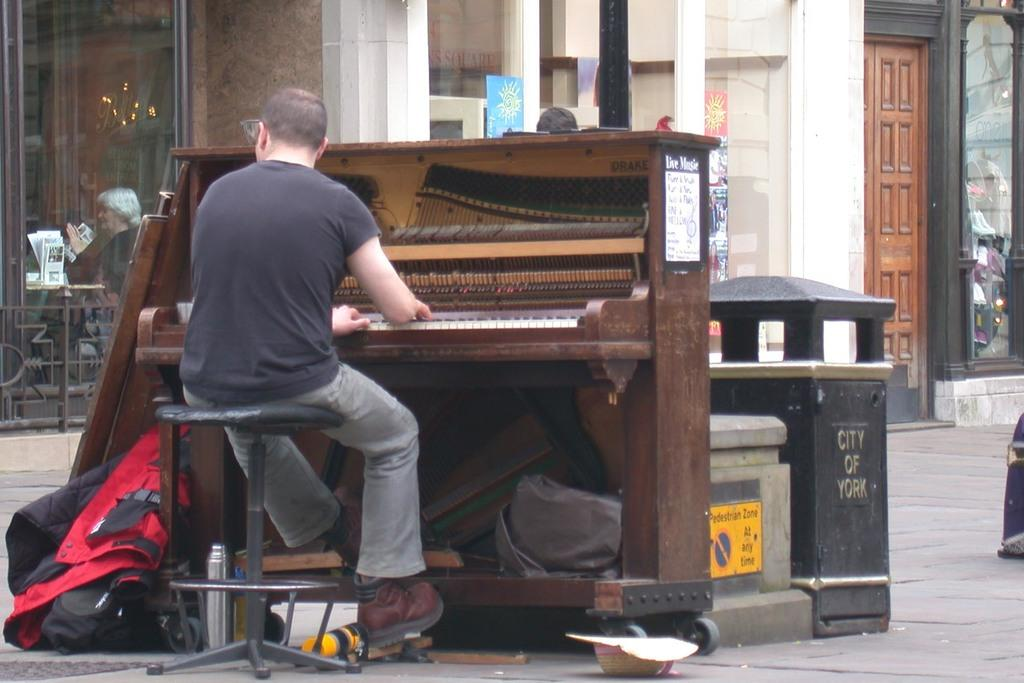Who is present in the image? There is a man in the image. What is the man doing in the image? The man is sitting on a stool in the image. What object is in front of the man? There is a keyboard in front of the man. What can be seen in the background of the image? Buildings are visible in the background of the image. How many people are present in the image? There is at least one person in the image, which is the man. What type of tax is being discussed in the image? There is no discussion of tax in the image; it features a man sitting on a stool with a keyboard in front of him. Is there any quicksand visible in the image? No, there is no quicksand present in the image. 